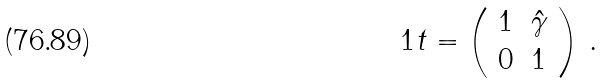Convert formula to latex. <formula><loc_0><loc_0><loc_500><loc_500>\ 1 t = \left ( \begin{array} { c c } 1 & \hat { \gamma } \\ 0 & 1 \end{array} \right ) \, .</formula> 